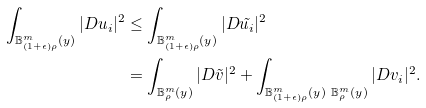<formula> <loc_0><loc_0><loc_500><loc_500>\int _ { \mathbb { B } _ { ( 1 + \epsilon ) \rho } ^ { m } ( y ) } | D u _ { i } | ^ { 2 } & \leq \int _ { \mathbb { B } _ { ( 1 + \epsilon ) \rho } ^ { m } ( y ) } | D \tilde { u _ { i } } | ^ { 2 } \\ & = \int _ { \mathbb { B } _ { \rho } ^ { m } ( y ) } | D \tilde { v } | ^ { 2 } + \int _ { \mathbb { B } _ { ( 1 + \epsilon ) \rho } ^ { m } ( y ) \ \mathbb { B } _ { \rho } ^ { m } ( y ) } | D v _ { i } | ^ { 2 } .</formula> 